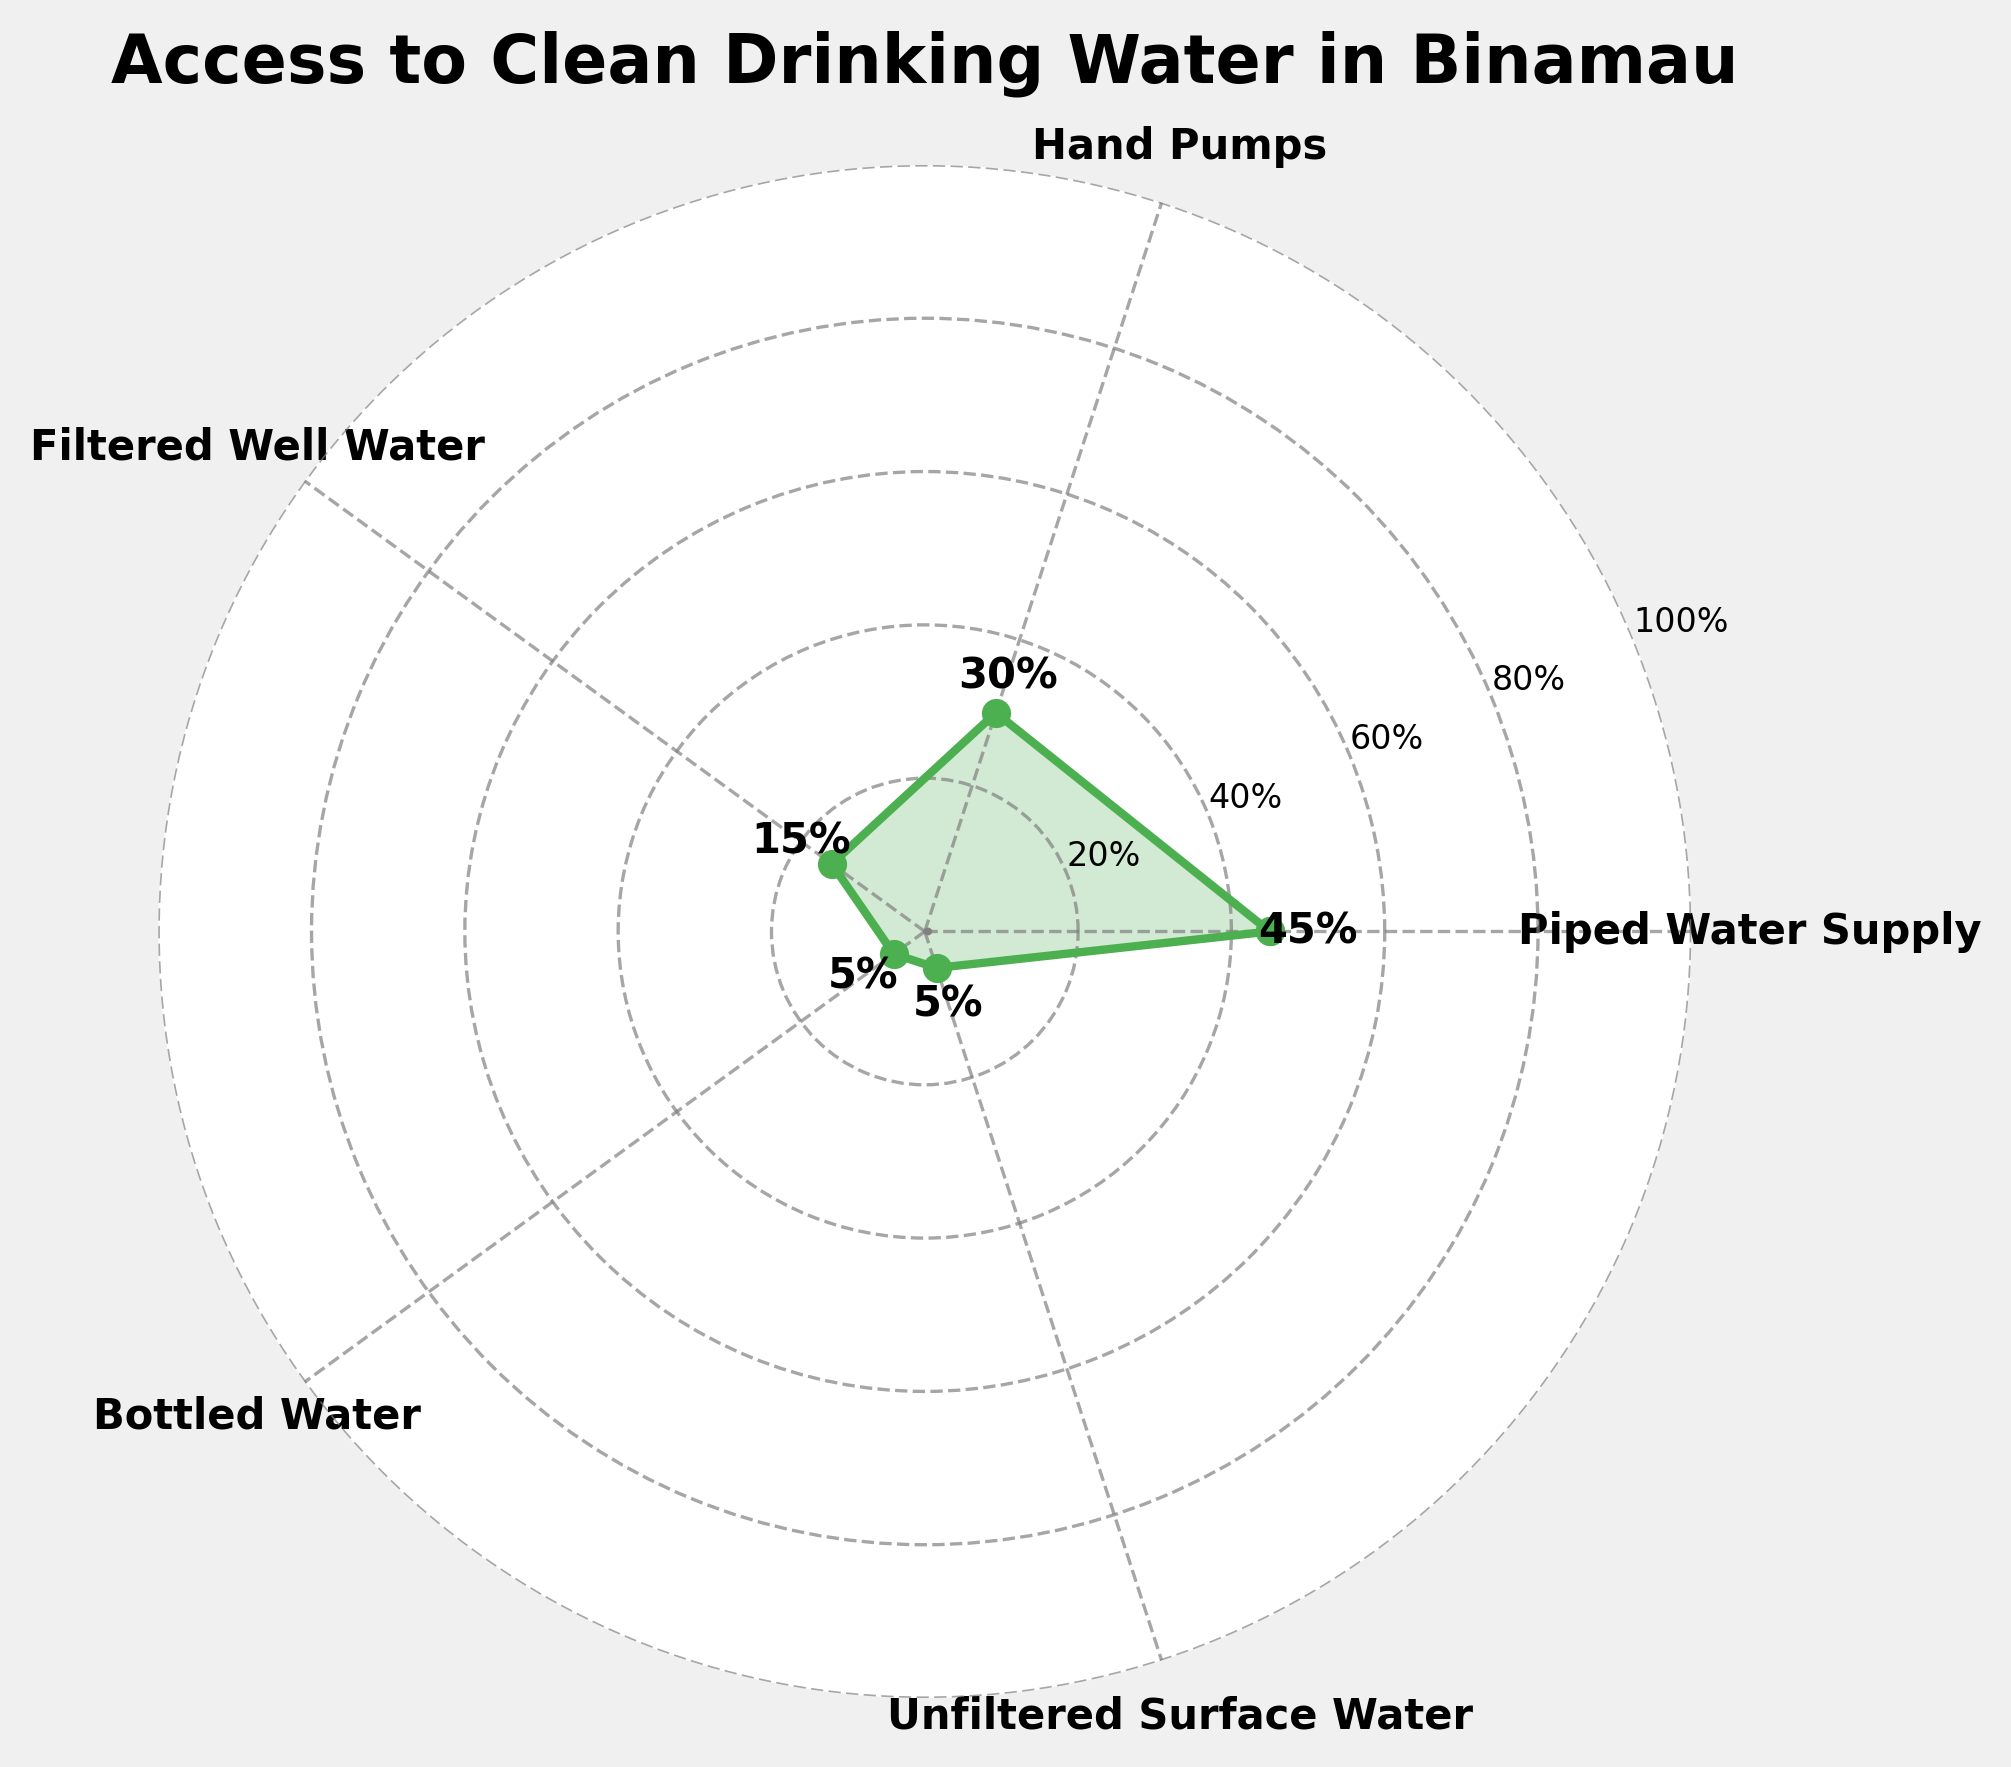Which type of drinking water source has the highest percentage of households using it? The plot shows various types of drinking water sources with their respective percentages. The highest percentage value in the plot is 45%, which corresponds to "Piped Water Supply."
Answer: Piped Water Supply What is the title of the chart? The title is located at the top center of the plot. It reads "Access to Clean Drinking Water in Binamau."
Answer: Access to Clean Drinking Water in Binamau How many types of drinking water sources are represented in the chart? The chart labels each type of drinking water source around the circular grid. There are five different types: "Piped Water Supply," "Hand Pumps," "Filtered Well Water," "Bottled Water," and "Unfiltered Surface Water."
Answer: Five What is the combined percentage of households using either Hand Pumps or Filtered Well Water? Sum the percentages for "Hand Pumps" and "Filtered Well Water." Hand Pumps account for 30%, and Filtered Well Water accounts for 15%. 30% + 15% = 45%.
Answer: 45% Which drinking water source has the smallest percentage of households using it, and what is that percentage? Identify the smallest value in the chart. The chart shows that "Unfiltered Surface Water" and "Bottled Water" both have the smallest percentage, which is 5%.
Answer: Unfiltered Surface Water and Bottled Water, 5% Are the y-axis labels consistent increments, and what do they range from? The y-axis labels are displayed at equal intervals, indicated by the percentages around the chart. They start at 20% and go up to 100%.
Answer: Yes, 20% to 100% How does the percentage of households using Hand Pumps compare to those using Bottled Water? Refer to the chart values for Hand Pumps and Bottled Water. Hand Pumps have a percentage of 30%, while Bottled Water has 5%. 30% is significantly higher than 5%.
Answer: Hand Pumps are higher What is the total percentage of households reported in the chart? Sum all the given percentages: 45% (Piped Water Supply) + 30% (Hand Pumps) + 15% (Filtered Well Water) + 5% (Bottled Water) + 5% (Unfiltered Surface Water). The total is 45% + 30% + 15% + 5% + 5% = 100%.
Answer: 100% What is the difference in percentage between households using Piped Water Supply and those using Hand Pumps? Subtract the percentage of Hand Pumps from that of Piped Water Supply. 45% (Piped Water Supply) - 30% (Hand Pumps) = 15%.
Answer: 15% Is there any water source used by fewer than 10% of households? Check the values of each water source on the plot. Both "Bottled Water" and "Unfiltered Surface Water" have percentages of 5%, which are fewer than 10%.
Answer: Yes 